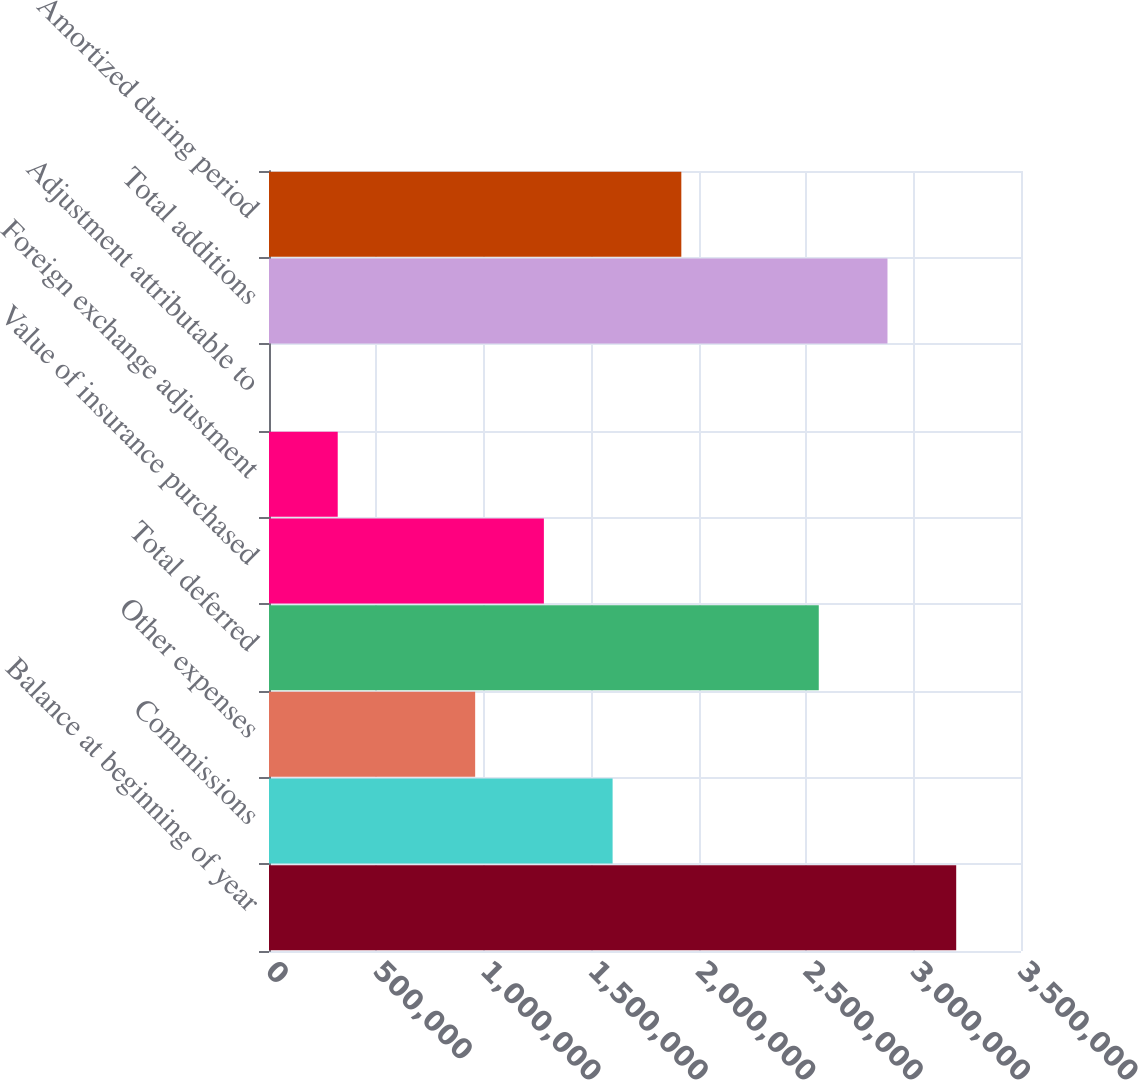Convert chart to OTSL. <chart><loc_0><loc_0><loc_500><loc_500><bar_chart><fcel>Balance at beginning of year<fcel>Commissions<fcel>Other expenses<fcel>Total deferred<fcel>Value of insurance purchased<fcel>Foreign exchange adjustment<fcel>Adjustment attributable to<fcel>Total additions<fcel>Amortized during period<nl><fcel>3.19843e+06<fcel>1.59922e+06<fcel>959531<fcel>2.55875e+06<fcel>1.27937e+06<fcel>319845<fcel>2.34<fcel>2.87859e+06<fcel>1.91906e+06<nl></chart> 